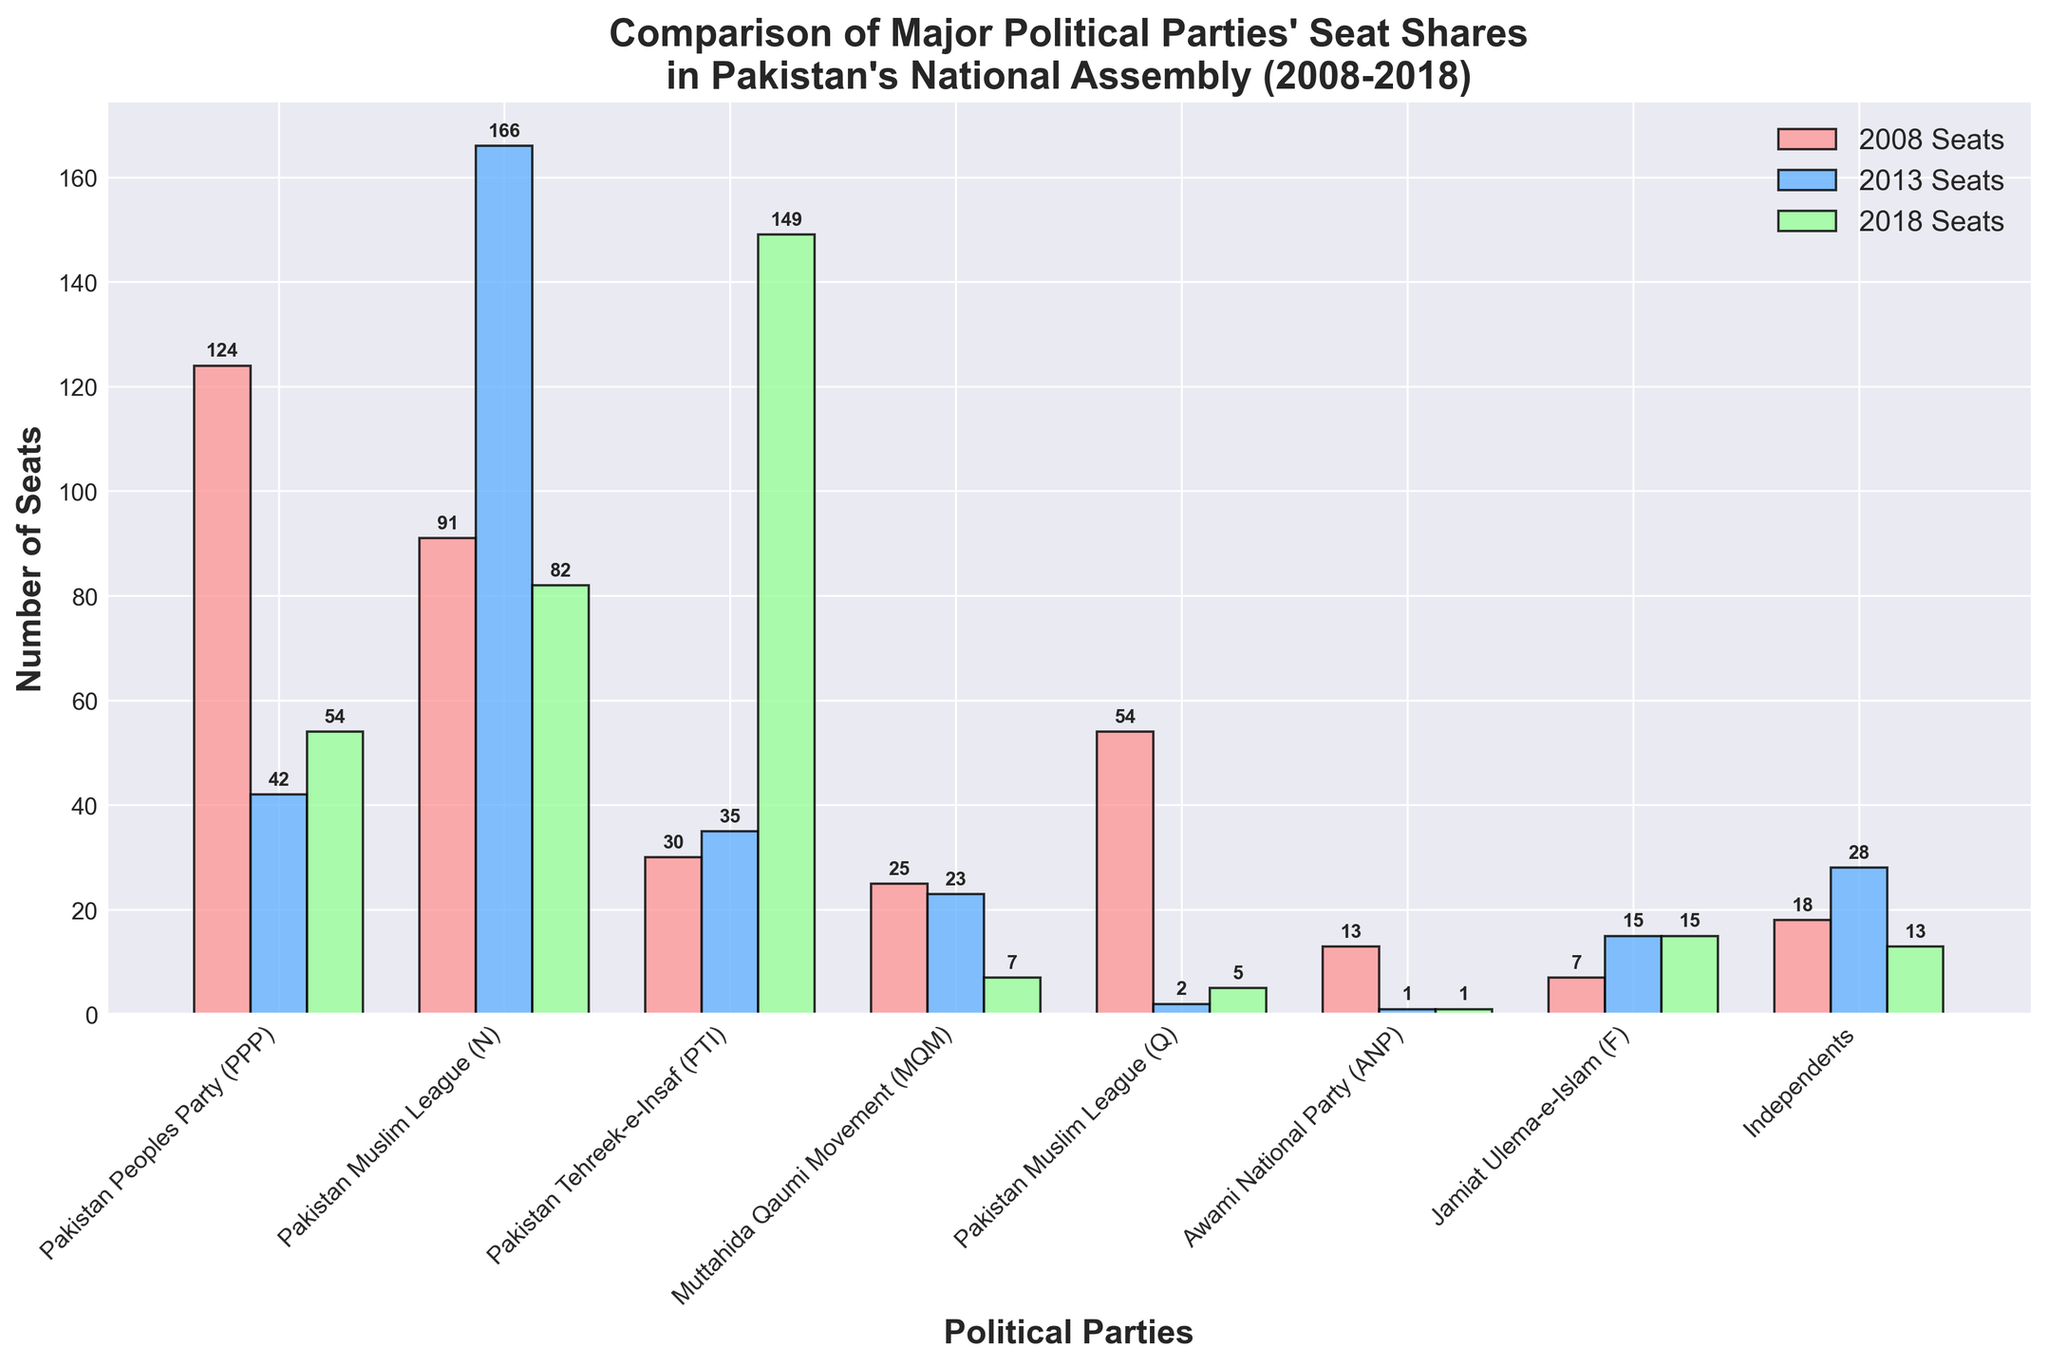What is the total number of seats won by PPP in all three elections? To find the total number of seats won by the Pakistan Peoples Party (PPP) in all three elections, sum up the seats from 2008, 2013, and 2018: 124 + 42 + 54 = 220
Answer: 220 Which party had the largest increase in seats from 2013 to 2018? Compare the seat changes for each party between 2013 and 2018. The PTI increased from 35 to 149 seats, which is the largest increase.
Answer: PTI In which year did the Pakistan Muslim League (N) win the most seats? Look at the seat numbers for Pakistan Muslim League (N) over the years. The highest value is 166 in 2013.
Answer: 2013 How does the number of seats won by MQM in 2008 compare to 2018? Compare the seat counts for MQM in 2008 and 2018. MQM had 25 seats in 2008 and 7 seats in 2018.
Answer: MQM had 18 more seats in 2008 Which party's seat count remained unchanged between 2013 and 2018? Check the seat numbers for each party between 2013 and 2018. The Jamiat Ulema-e-Islam (F) had 15 seats in both 2013 and 2018.
Answer: Jamiat Ulema-e-Islam (F) What is the average number of seats won by Pakistan Peoples Party (PPP) across the three elections? The total seats won by PPP over the three years are 124 + 42 + 54 = 220. To find the average: 220 / 3 = 73.33
Answer: 73.33 Which two parties experienced the largest drop in seat count from 2008 to 2013? Check the differences in seat counts for each party between 2008 and 2013. The largest drops are for Pakistan Peoples Party (PPP) (124 to 42) and Pakistan Muslim League (Q) (54 to 2).
Answer: PPP & PML(Q) What is the total seat count for Independents over all years combined? Sum up the seats won by Independents in all three elections: 18 + 28 + 13 = 59
Answer: 59 Which party had the smallest overall change in seat count from 2008 to 2018? Calculate the changes for each party from 2008 to 2018. The Awami National Party (ANP) went from 13 seats in 2008 to 1 seat in 2018, resulting in a change of -12 seats. Cross-verify this with others to find the smallest change.
Answer: ANP had a change of -12 How many more seats did PTI win in 2018 compared to 2013? Subtract the number of seats PTI won in 2013 from its 2018 count: 149 - 35 = 114
Answer: 114 